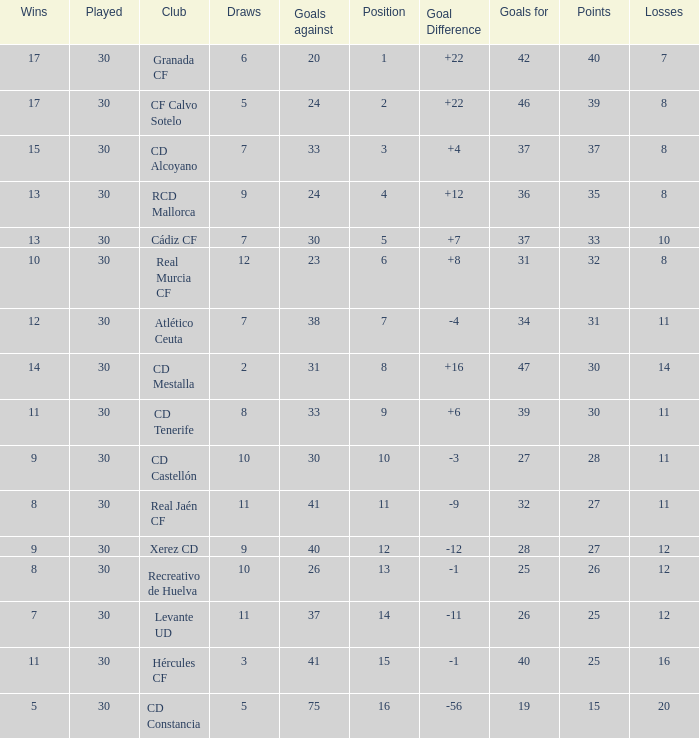Which Wins have a Goal Difference larger than 12, and a Club of granada cf, and Played larger than 30? None. 